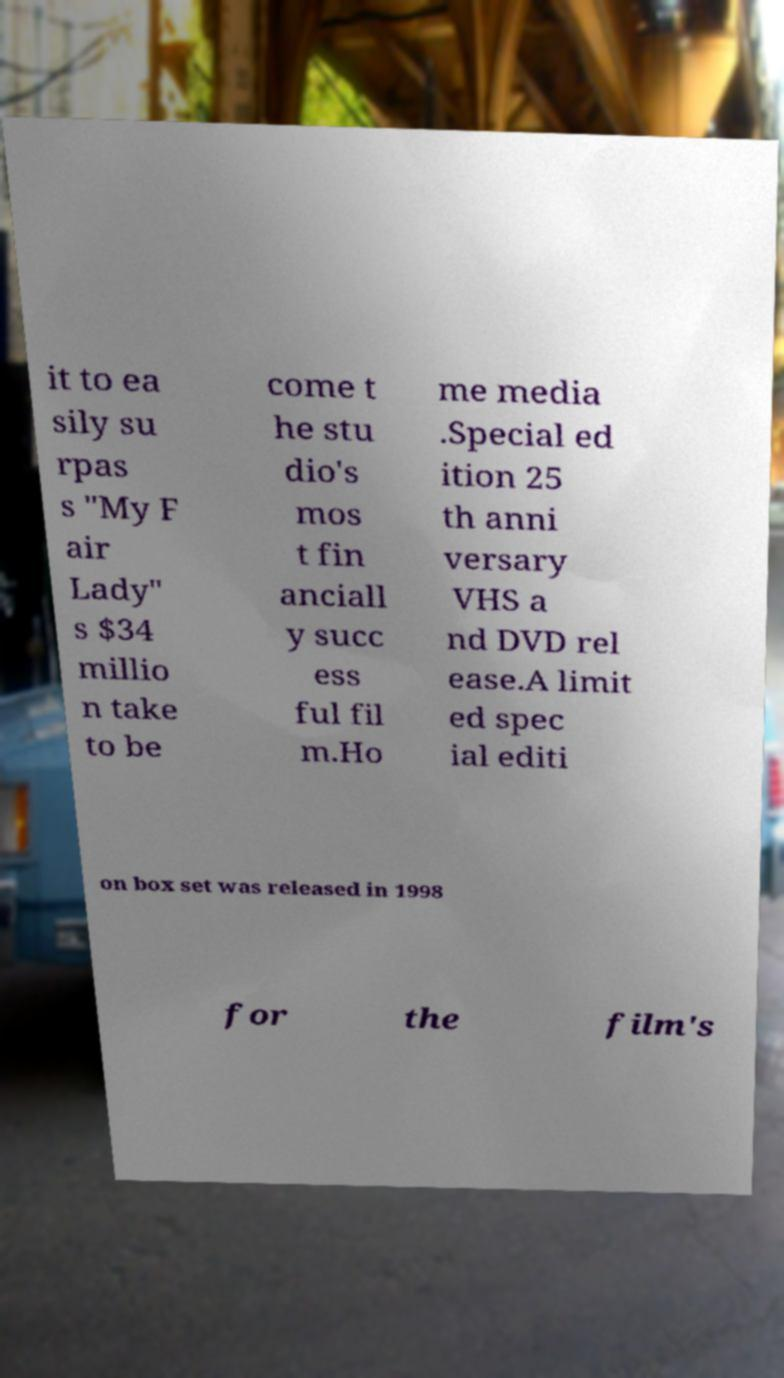What messages or text are displayed in this image? I need them in a readable, typed format. it to ea sily su rpas s "My F air Lady" s $34 millio n take to be come t he stu dio's mos t fin anciall y succ ess ful fil m.Ho me media .Special ed ition 25 th anni versary VHS a nd DVD rel ease.A limit ed spec ial editi on box set was released in 1998 for the film's 